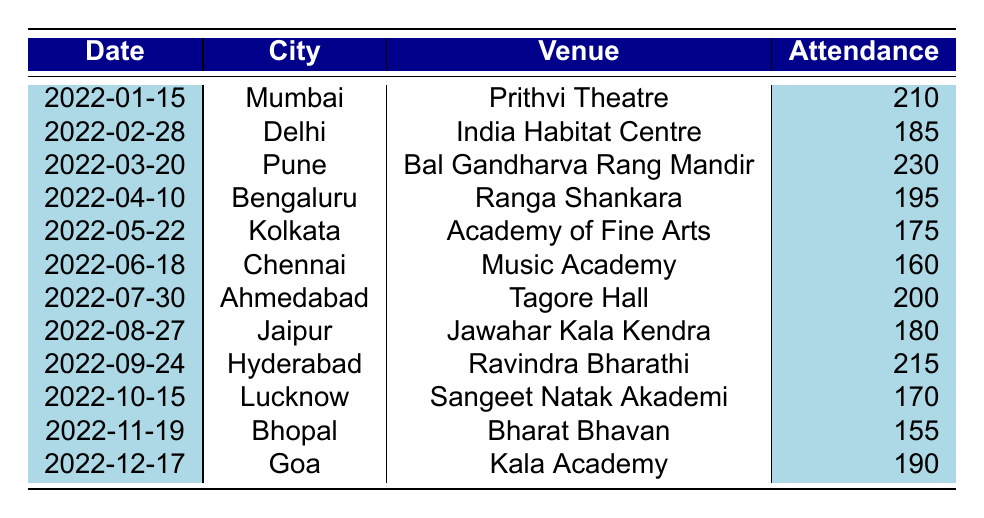What was the attendance at the puppet show in Pune? The attendance in Pune on March 20, 2022, was recorded as 230.
Answer: 230 Which city had the lowest attendance at Satyajit Padhye's shows? The attendance in Bhopal on November 19, 2022, was the lowest at 155.
Answer: 155 What is the average attendance across all venues? To calculate the average attendance, sum all attendance values (210 + 185 + 230 + 195 + 175 + 160 + 200 + 180 + 215 + 170 + 155 + 190 = 2,150) and divide by the number of shows (12). So, the average attendance is 2,150 / 12 ≈ 179.17.
Answer: 179.17 Did Satyajit Padhye perform in Chennai? Yes, there was a puppet show in Chennai on June 18, 2022.
Answer: Yes Which venue had the highest attendance and what was the number? The venue with the highest attendance was Bal Gandharva Rang Mandir in Pune, with an attendance of 230 on March 20, 2022.
Answer: 230 How many cities had an attendance of more than 200? There are 4 cities (Mumbai, Pune, Hyderabad, and Ahmedabad) that had attendance over 200 (210, 230, 215, and 200 respectively).
Answer: 4 What was the attendance difference between the highest and lowest attended shows? The highest attendance was 230 (Pune) and the lowest was 155 (Bhopal). The difference is 230 - 155 = 75.
Answer: 75 In how many cities was the attendance below 180? The cities where attendance was below 180 are Kolkata (175), Chennai (160), Jaipur (180) and Bhopal (155). Therefore, there are 3 cities below 180 excluding Jaipur.
Answer: 3 What venue had an attendance of exactly 170? The venue with an attendance of exactly 170 is Sangeet Natak Akademi in Lucknow on October 15, 2022.
Answer: Sangeet Natak Akademi Which month had the show with the highest attendance? The show with the highest attendance occurred in March (Pune) with 230 attendees.
Answer: March 